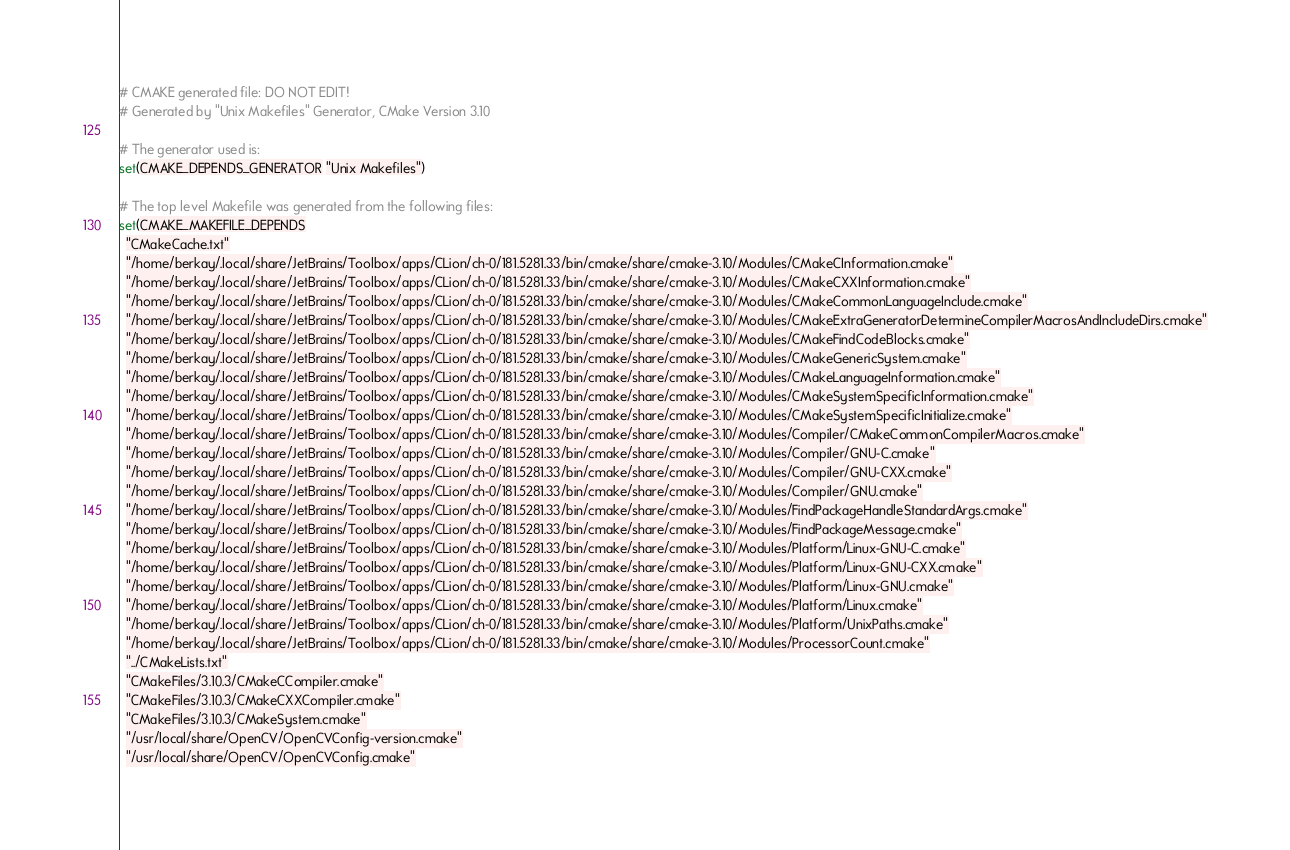<code> <loc_0><loc_0><loc_500><loc_500><_CMake_># CMAKE generated file: DO NOT EDIT!
# Generated by "Unix Makefiles" Generator, CMake Version 3.10

# The generator used is:
set(CMAKE_DEPENDS_GENERATOR "Unix Makefiles")

# The top level Makefile was generated from the following files:
set(CMAKE_MAKEFILE_DEPENDS
  "CMakeCache.txt"
  "/home/berkay/.local/share/JetBrains/Toolbox/apps/CLion/ch-0/181.5281.33/bin/cmake/share/cmake-3.10/Modules/CMakeCInformation.cmake"
  "/home/berkay/.local/share/JetBrains/Toolbox/apps/CLion/ch-0/181.5281.33/bin/cmake/share/cmake-3.10/Modules/CMakeCXXInformation.cmake"
  "/home/berkay/.local/share/JetBrains/Toolbox/apps/CLion/ch-0/181.5281.33/bin/cmake/share/cmake-3.10/Modules/CMakeCommonLanguageInclude.cmake"
  "/home/berkay/.local/share/JetBrains/Toolbox/apps/CLion/ch-0/181.5281.33/bin/cmake/share/cmake-3.10/Modules/CMakeExtraGeneratorDetermineCompilerMacrosAndIncludeDirs.cmake"
  "/home/berkay/.local/share/JetBrains/Toolbox/apps/CLion/ch-0/181.5281.33/bin/cmake/share/cmake-3.10/Modules/CMakeFindCodeBlocks.cmake"
  "/home/berkay/.local/share/JetBrains/Toolbox/apps/CLion/ch-0/181.5281.33/bin/cmake/share/cmake-3.10/Modules/CMakeGenericSystem.cmake"
  "/home/berkay/.local/share/JetBrains/Toolbox/apps/CLion/ch-0/181.5281.33/bin/cmake/share/cmake-3.10/Modules/CMakeLanguageInformation.cmake"
  "/home/berkay/.local/share/JetBrains/Toolbox/apps/CLion/ch-0/181.5281.33/bin/cmake/share/cmake-3.10/Modules/CMakeSystemSpecificInformation.cmake"
  "/home/berkay/.local/share/JetBrains/Toolbox/apps/CLion/ch-0/181.5281.33/bin/cmake/share/cmake-3.10/Modules/CMakeSystemSpecificInitialize.cmake"
  "/home/berkay/.local/share/JetBrains/Toolbox/apps/CLion/ch-0/181.5281.33/bin/cmake/share/cmake-3.10/Modules/Compiler/CMakeCommonCompilerMacros.cmake"
  "/home/berkay/.local/share/JetBrains/Toolbox/apps/CLion/ch-0/181.5281.33/bin/cmake/share/cmake-3.10/Modules/Compiler/GNU-C.cmake"
  "/home/berkay/.local/share/JetBrains/Toolbox/apps/CLion/ch-0/181.5281.33/bin/cmake/share/cmake-3.10/Modules/Compiler/GNU-CXX.cmake"
  "/home/berkay/.local/share/JetBrains/Toolbox/apps/CLion/ch-0/181.5281.33/bin/cmake/share/cmake-3.10/Modules/Compiler/GNU.cmake"
  "/home/berkay/.local/share/JetBrains/Toolbox/apps/CLion/ch-0/181.5281.33/bin/cmake/share/cmake-3.10/Modules/FindPackageHandleStandardArgs.cmake"
  "/home/berkay/.local/share/JetBrains/Toolbox/apps/CLion/ch-0/181.5281.33/bin/cmake/share/cmake-3.10/Modules/FindPackageMessage.cmake"
  "/home/berkay/.local/share/JetBrains/Toolbox/apps/CLion/ch-0/181.5281.33/bin/cmake/share/cmake-3.10/Modules/Platform/Linux-GNU-C.cmake"
  "/home/berkay/.local/share/JetBrains/Toolbox/apps/CLion/ch-0/181.5281.33/bin/cmake/share/cmake-3.10/Modules/Platform/Linux-GNU-CXX.cmake"
  "/home/berkay/.local/share/JetBrains/Toolbox/apps/CLion/ch-0/181.5281.33/bin/cmake/share/cmake-3.10/Modules/Platform/Linux-GNU.cmake"
  "/home/berkay/.local/share/JetBrains/Toolbox/apps/CLion/ch-0/181.5281.33/bin/cmake/share/cmake-3.10/Modules/Platform/Linux.cmake"
  "/home/berkay/.local/share/JetBrains/Toolbox/apps/CLion/ch-0/181.5281.33/bin/cmake/share/cmake-3.10/Modules/Platform/UnixPaths.cmake"
  "/home/berkay/.local/share/JetBrains/Toolbox/apps/CLion/ch-0/181.5281.33/bin/cmake/share/cmake-3.10/Modules/ProcessorCount.cmake"
  "../CMakeLists.txt"
  "CMakeFiles/3.10.3/CMakeCCompiler.cmake"
  "CMakeFiles/3.10.3/CMakeCXXCompiler.cmake"
  "CMakeFiles/3.10.3/CMakeSystem.cmake"
  "/usr/local/share/OpenCV/OpenCVConfig-version.cmake"
  "/usr/local/share/OpenCV/OpenCVConfig.cmake"</code> 